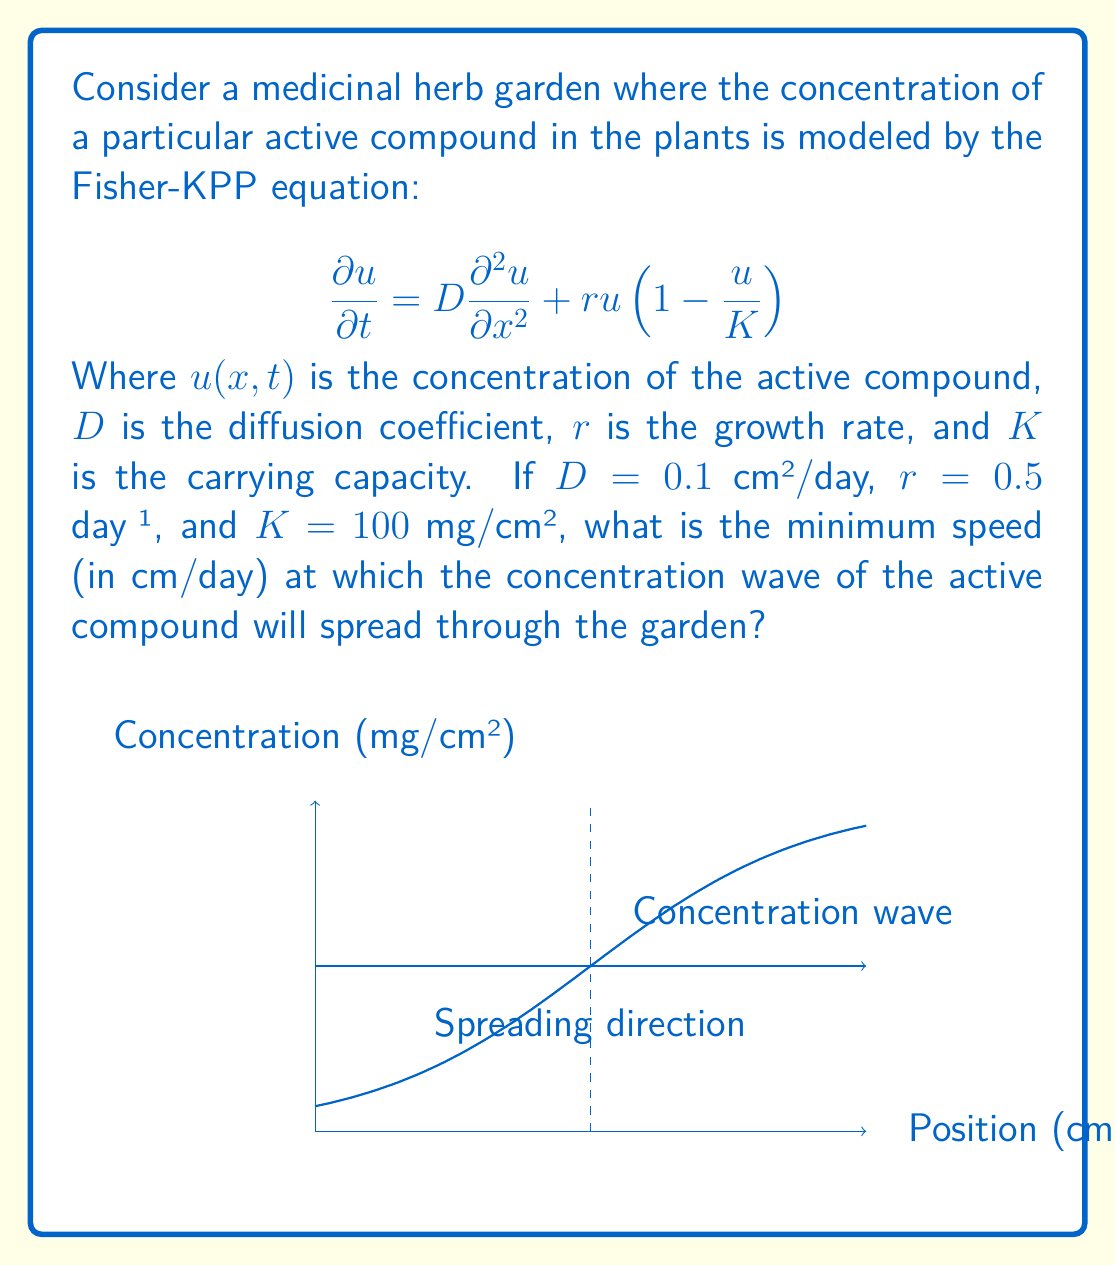Give your solution to this math problem. To solve this problem, we'll follow these steps:

1) The Fisher-KPP equation is a reaction-diffusion equation that models the spread of a population (or in this case, a compound concentration) in space and time.

2) For such equations, there exists a minimum wave speed at which the concentration front propagates. This minimum speed is given by the formula:

   $$c_{min} = 2\sqrt{rD}$$

   Where $c_{min}$ is the minimum wave speed, $r$ is the growth rate, and $D$ is the diffusion coefficient.

3) We are given:
   $D = 0.1$ cm²/day
   $r = 0.5$ day⁻¹
   $K = 100$ mg/cm² (not needed for this calculation)

4) Let's substitute these values into the formula:

   $$c_{min} = 2\sqrt{(0.5\text{ day}^{-1})(0.1\text{ cm}^2/\text{day})}$$

5) Simplify under the square root:

   $$c_{min} = 2\sqrt{0.05\text{ cm}^2/\text{day}^2}$$

6) Calculate:

   $$c_{min} = 2\sqrt{0.05} \text{ cm/day} \approx 0.4472\text{ cm/day}$$

Therefore, the minimum speed at which the concentration wave will spread is approximately 0.4472 cm/day.
Answer: $0.4472\text{ cm/day}$ 